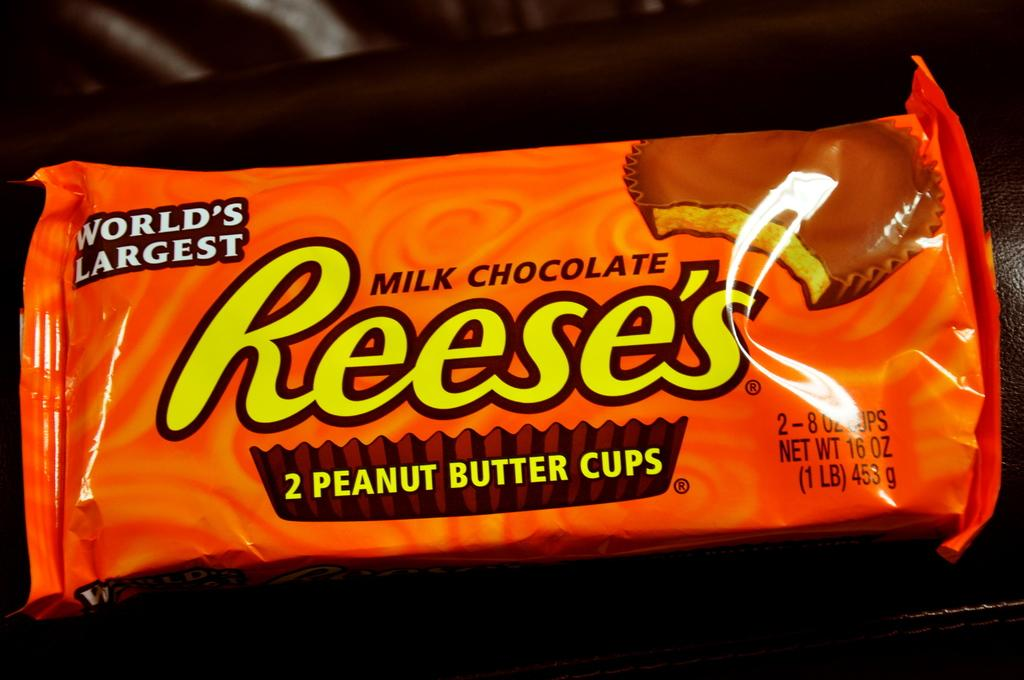<image>
Relay a brief, clear account of the picture shown. An orange Reese's milk chocolate candy bar sits on a table. 